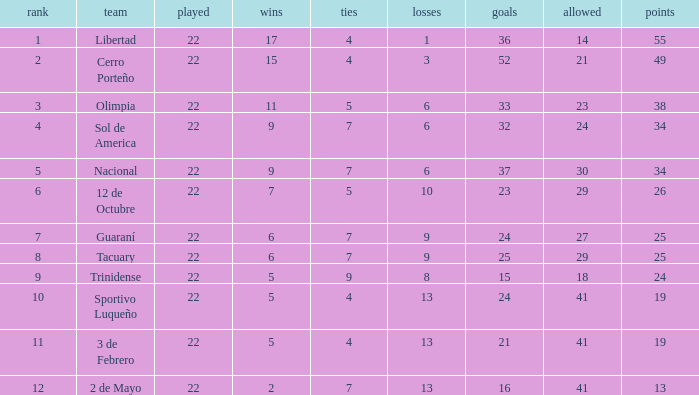What is the fewest wins that has fewer than 23 goals scored, team of 2 de Mayo, and fewer than 7 draws? None. Would you be able to parse every entry in this table? {'header': ['rank', 'team', 'played', 'wins', 'ties', 'losses', 'goals', 'allowed', 'points'], 'rows': [['1', 'Libertad', '22', '17', '4', '1', '36', '14', '55'], ['2', 'Cerro Porteño', '22', '15', '4', '3', '52', '21', '49'], ['3', 'Olimpia', '22', '11', '5', '6', '33', '23', '38'], ['4', 'Sol de America', '22', '9', '7', '6', '32', '24', '34'], ['5', 'Nacional', '22', '9', '7', '6', '37', '30', '34'], ['6', '12 de Octubre', '22', '7', '5', '10', '23', '29', '26'], ['7', 'Guaraní', '22', '6', '7', '9', '24', '27', '25'], ['8', 'Tacuary', '22', '6', '7', '9', '25', '29', '25'], ['9', 'Trinidense', '22', '5', '9', '8', '15', '18', '24'], ['10', 'Sportivo Luqueño', '22', '5', '4', '13', '24', '41', '19'], ['11', '3 de Febrero', '22', '5', '4', '13', '21', '41', '19'], ['12', '2 de Mayo', '22', '2', '7', '13', '16', '41', '13']]} 